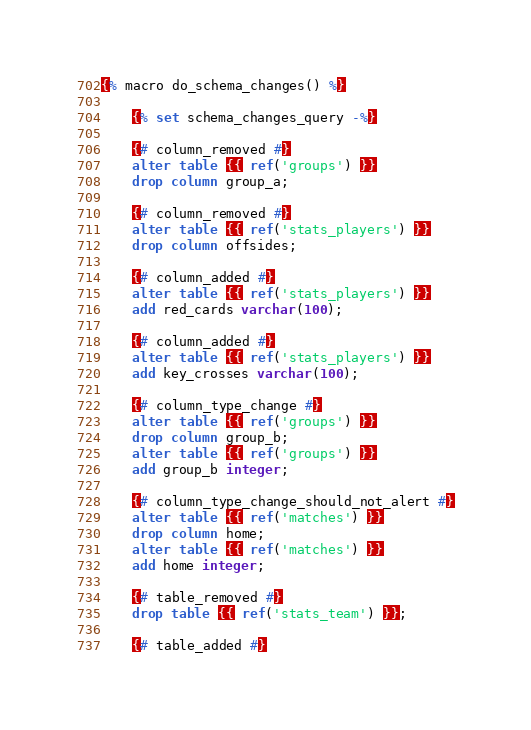<code> <loc_0><loc_0><loc_500><loc_500><_SQL_>{% macro do_schema_changes() %}

    {% set schema_changes_query -%}

    {# column_removed #}
    alter table {{ ref('groups') }}
    drop column group_a;

    {# column_removed #}
    alter table {{ ref('stats_players') }}
    drop column offsides;

    {# column_added #}
    alter table {{ ref('stats_players') }}
    add red_cards varchar(100);

    {# column_added #}
    alter table {{ ref('stats_players') }}
    add key_crosses varchar(100);

    {# column_type_change #}
    alter table {{ ref('groups') }}
    drop column group_b;
    alter table {{ ref('groups') }}
    add group_b integer;

    {# column_type_change_should_not_alert #}
    alter table {{ ref('matches') }}
    drop column home;
    alter table {{ ref('matches') }}
    add home integer;

    {# table_removed #}
    drop table {{ ref('stats_team') }};

    {# table_added #}</code> 